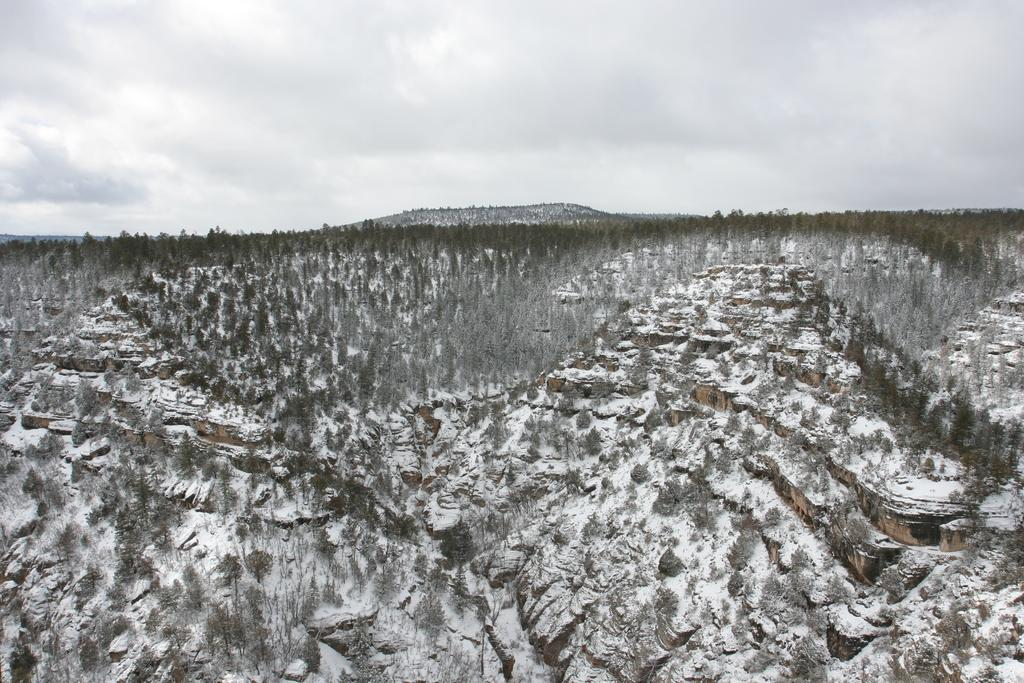What type of location is depicted in the image? The image is taken in a hill area. What can be seen growing in the hill area? There are plants in the image. What weather condition is present in the image? There is snow in the image. What is visible in the background of the image? The sky is visible in the background of the image. How would you describe the sky in the image? The sky is cloudy in the image. What word is being written by the hand in the image? There is no hand or word present in the image. What type of paste is being used to stick the plants together in the image? There is no paste or indication of sticking plants together in the image. 